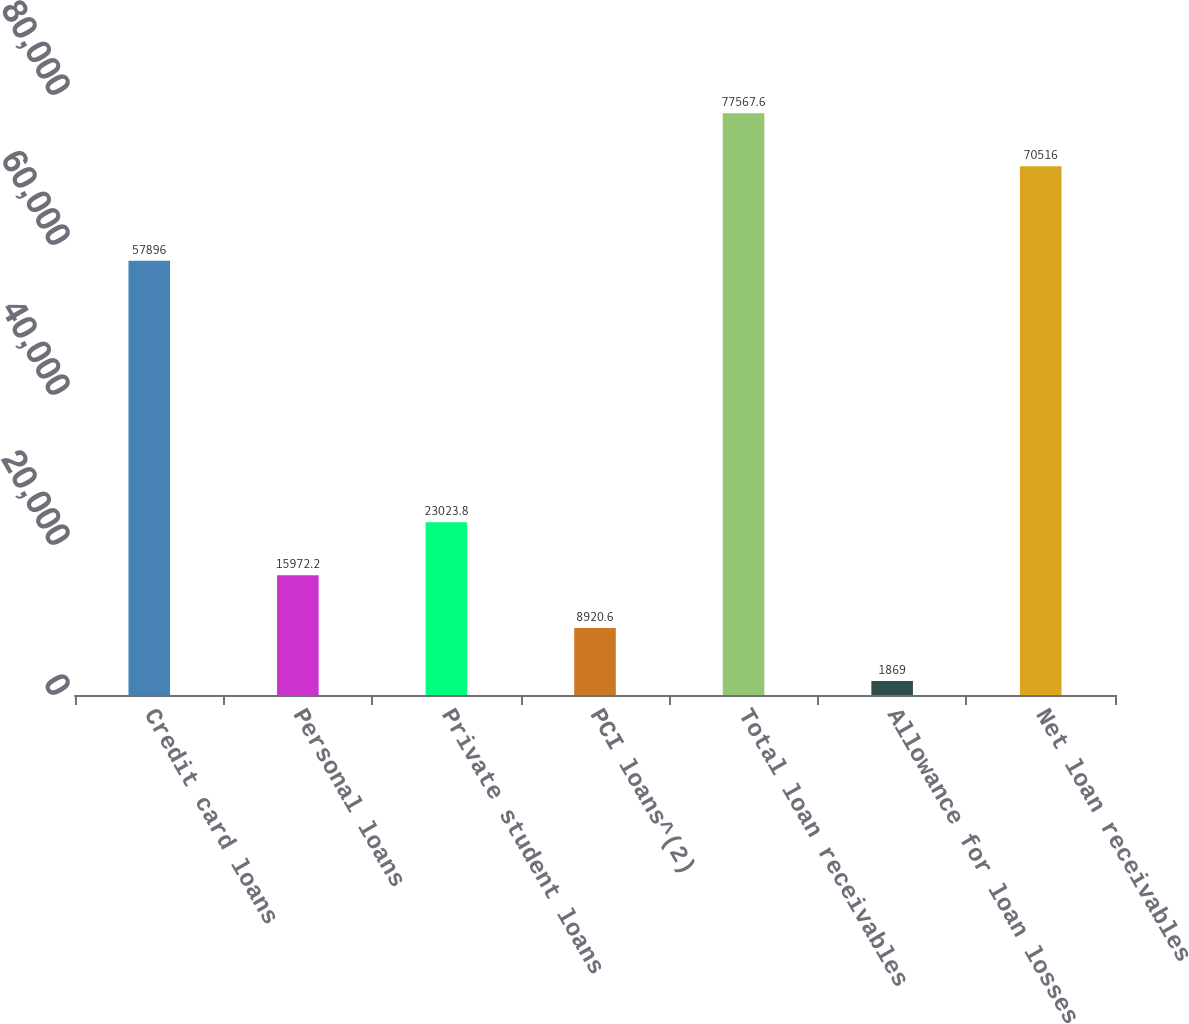Convert chart to OTSL. <chart><loc_0><loc_0><loc_500><loc_500><bar_chart><fcel>Credit card loans<fcel>Personal loans<fcel>Private student loans<fcel>PCI loans^(2)<fcel>Total loan receivables<fcel>Allowance for loan losses<fcel>Net loan receivables<nl><fcel>57896<fcel>15972.2<fcel>23023.8<fcel>8920.6<fcel>77567.6<fcel>1869<fcel>70516<nl></chart> 